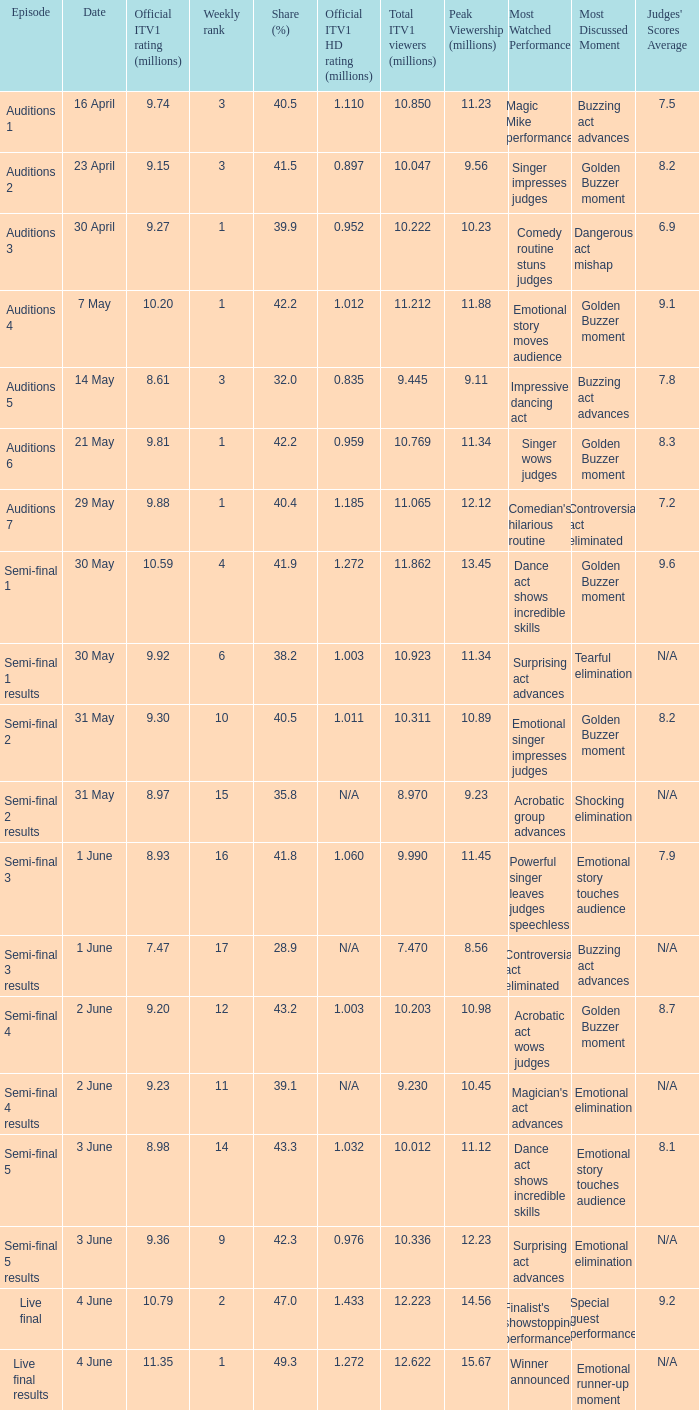What was the official ITV1 rating in millions of the Live Final Results episode? 11.35. 